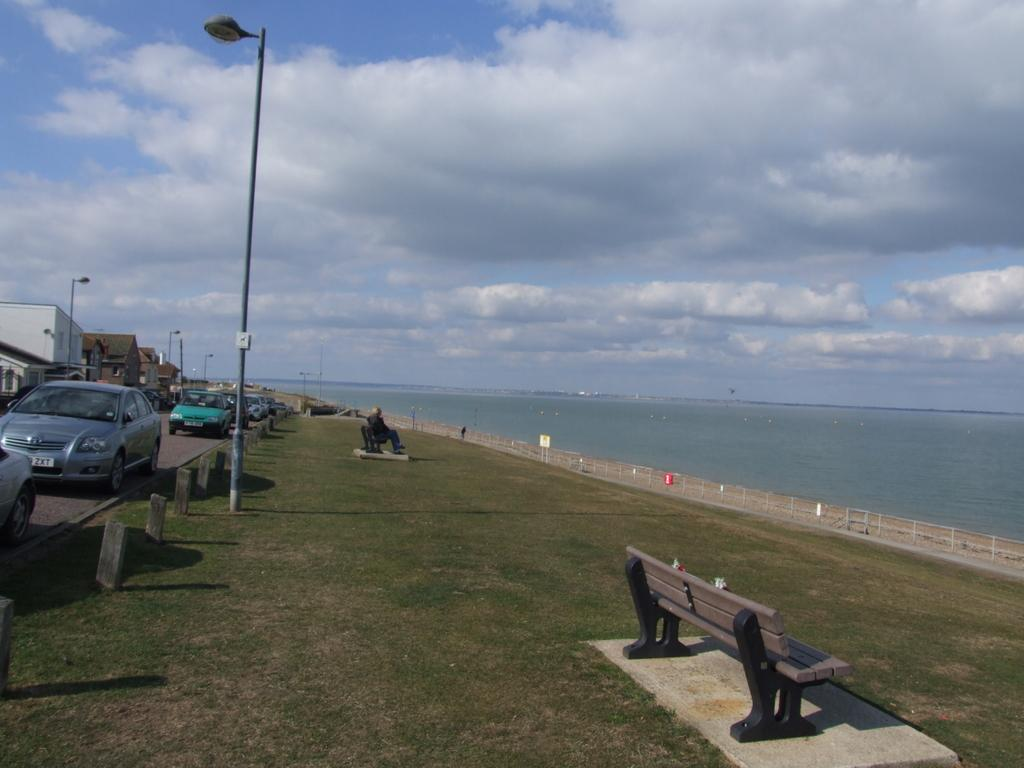What can be seen in large numbers in the image? There are many vehicles in the image. What structure is present in the image? There is a light pole in the image. What is the person in the image doing? There is a person sitting on a bench in the image. What natural feature is visible in the image? There is a river in the image. How would you describe the weather in the image? The sky is cloudy in the image. What type of quilt is being used to match the colors of the vehicles in the image? There is no quilt present in the image, and the colors of the vehicles are not being matched to any other object. How does the person on the bench roll down the river in the image? The person on the bench is not rolling down the river; they are sitting on a bench. 